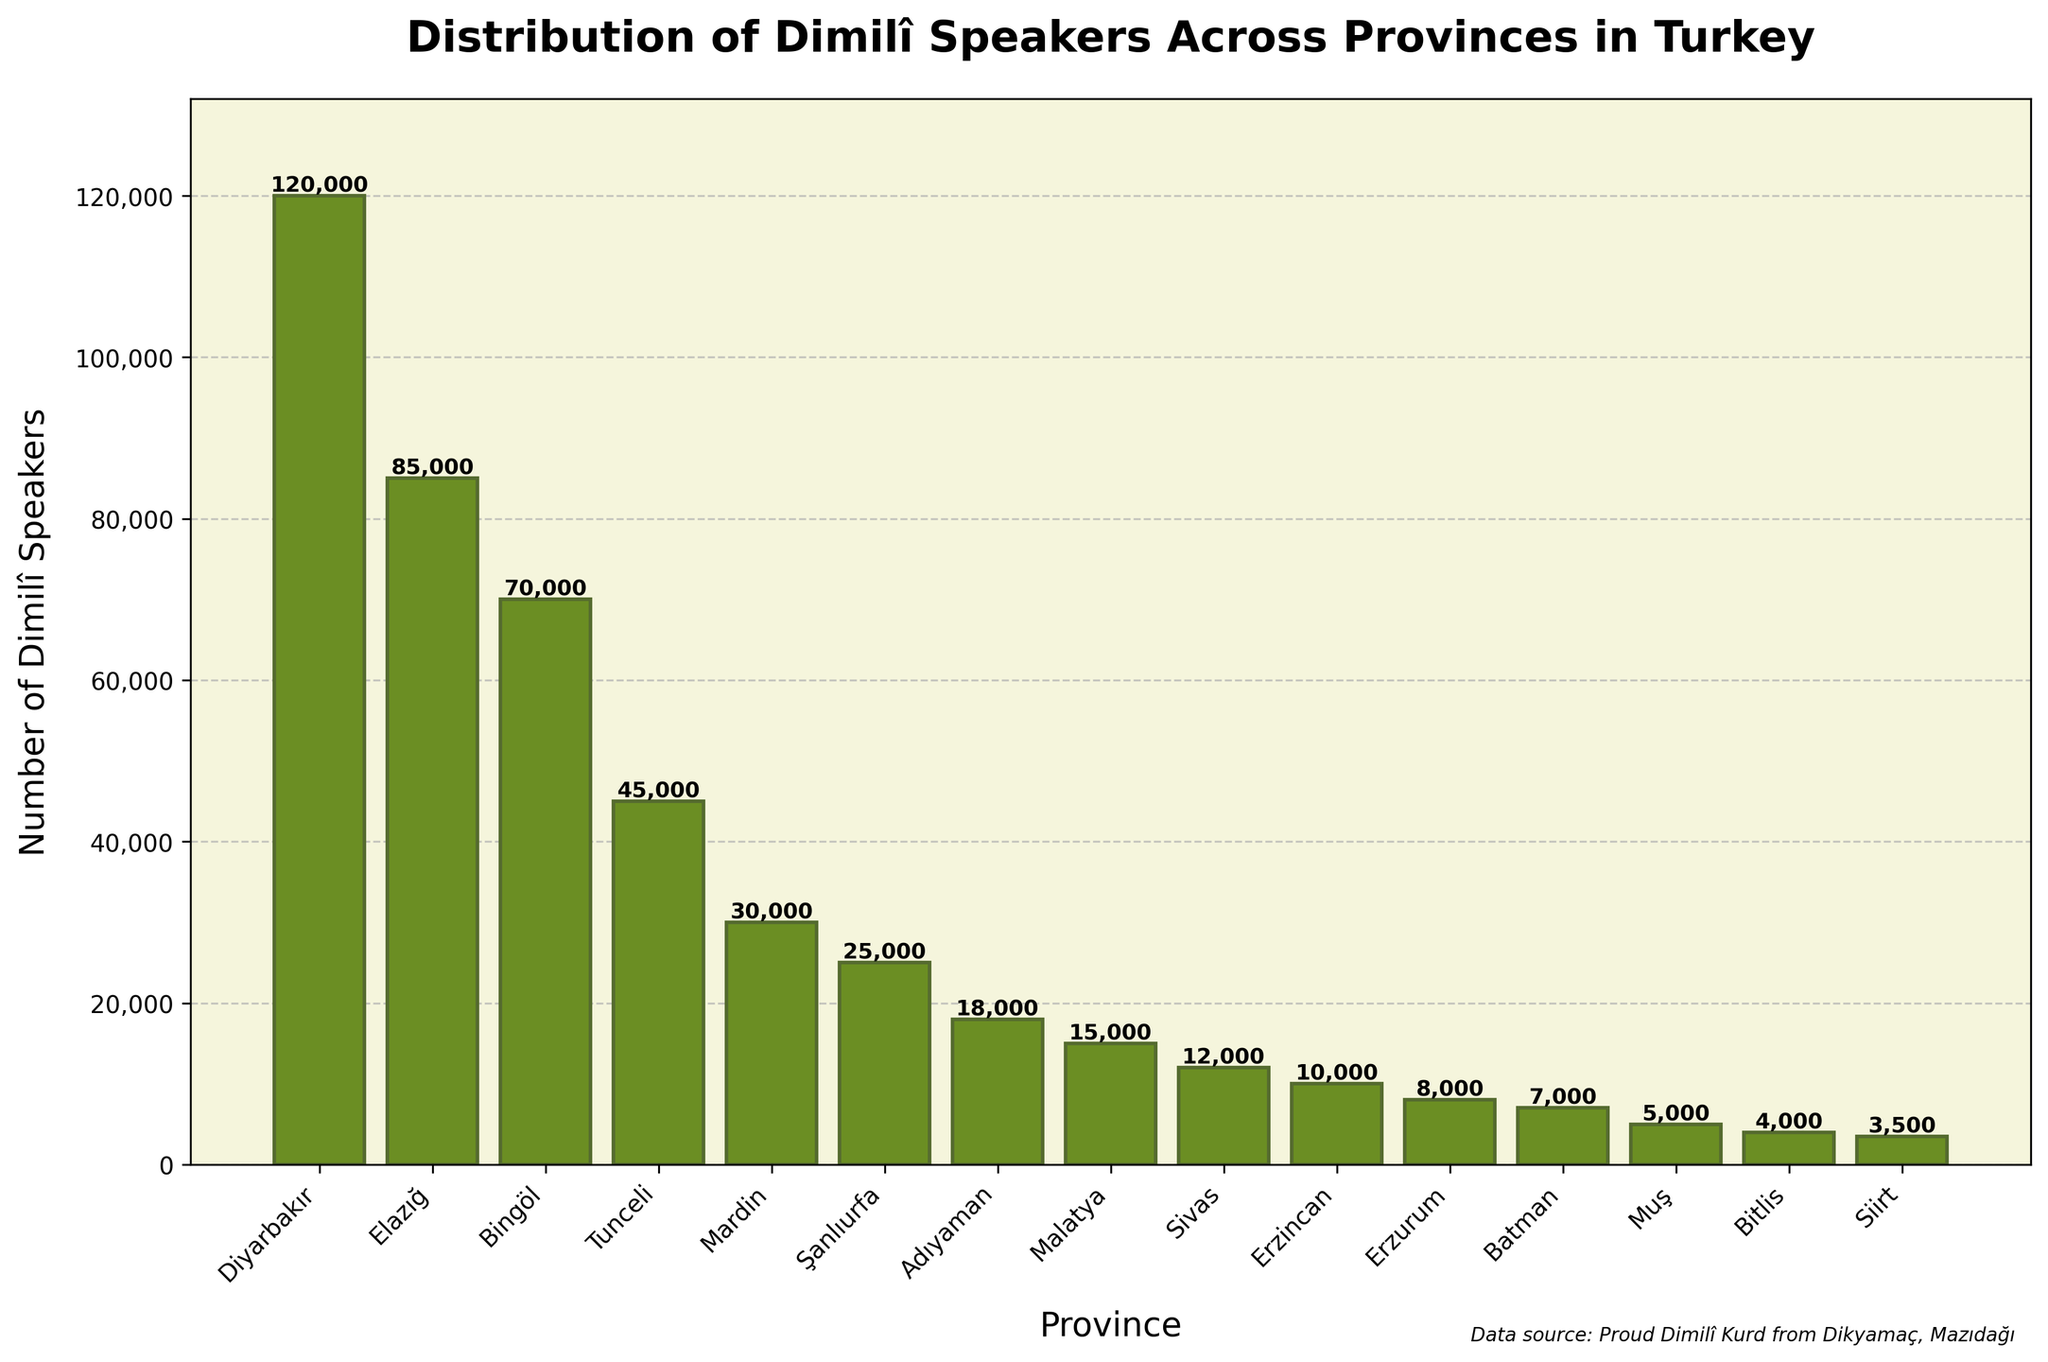Which province has the highest number of Dimilî speakers? By looking at the height of the bars on the figure, Diyarbakır has the tallest bar, indicating it has the highest number of Dimilî speakers.
Answer: Diyarbakır What is the total number of Dimilî speakers in Elazığ, Bingöl, and Tunceli combined? The number of Dimilî speakers in Elazığ is 85,000, in Bingöl is 70,000, and in Tunceli is 45,000. Adding these numbers together gives 85,000 + 70,000 + 45,000 = 200,000.
Answer: 200,000 Which province has fewer Dimilî speakers, Batman or Muş? Comparing the heights of the bars for Batman and Muş, the bar for Muş is shorter, indicating Muş has fewer speakers. Batman has 7,000, and Muş has 5,000.
Answer: Muş What is the difference in the number of Dimilî speakers between Mardin and Şanlıurfa? The figure shows Mardin has 30,000 Dimilî speakers, while Şanlıurfa has 25,000. The difference is 30,000 - 25,000 = 5,000.
Answer: 5,000 What is the average number of Dimilî speakers in Sivas, Erzincan, and Erzurum? The numbers of Dimilî speakers in Sivas, Erzincan, and Erzurum are 12,000, 10,000, and 8,000 respectively. Summing these up gives 12,000 + 10,000 + 8,000 = 30,000; dividing by 3 gives 30,000 / 3 = 10,000.
Answer: 10,000 Out of Elazığ, Tunceli, and Adıyaman, which province has the fewest Dimilî speakers? Referring to the bars’ heights for the three provinces, Adıyaman has the lowest bar. Elazığ has 85,000, Tunceli has 45,000, and Adıyaman has 18,000.
Answer: Adıyaman By how much do the number of Dimilî speakers in Diyarbakır exceed the total number in Malatya and Bingöl? Diyarbakır has 120,000 Dimilî speakers. Malatya has 15,000, and Bingöl has 70,000. Summing Malatya and Bingöl gives 15,000 + 70,000 = 85,000. The difference is 120,000 - 85,000 = 35,000.
Answer: 35,000 Which provinces have fewer than 10,000 Dimilî speakers? From the chart, the bars lower than 10,000 represent Erzurum (8,000), Batman (7,000), Muş (5,000), Bitlis (4,000), and Siirt (3,500).
Answer: Erzurum, Batman, Muş, Bitlis, Siirt What is the combined total of Dimilî speakers from the two provinces with the lowest populations? The two provinces with the shortest bars are Siirt (3,500) and Bitlis (4,000). Adding these gives 3,500 + 4,000 = 7,500.
Answer: 7,500 